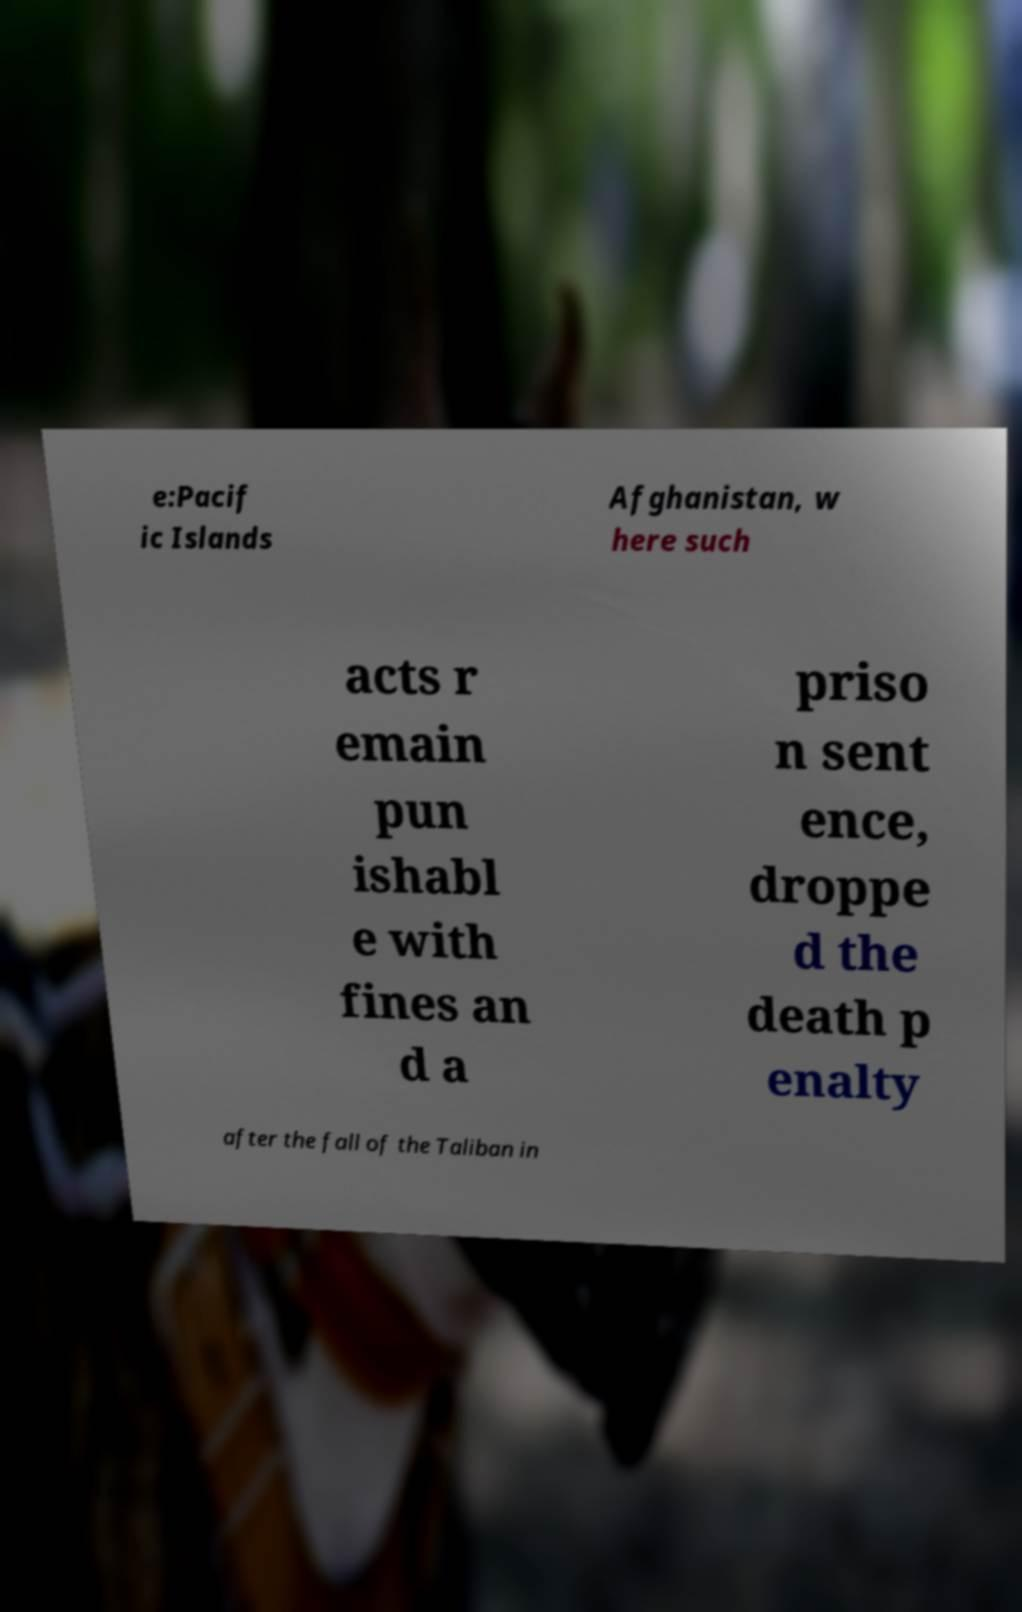Please identify and transcribe the text found in this image. e:Pacif ic Islands Afghanistan, w here such acts r emain pun ishabl e with fines an d a priso n sent ence, droppe d the death p enalty after the fall of the Taliban in 